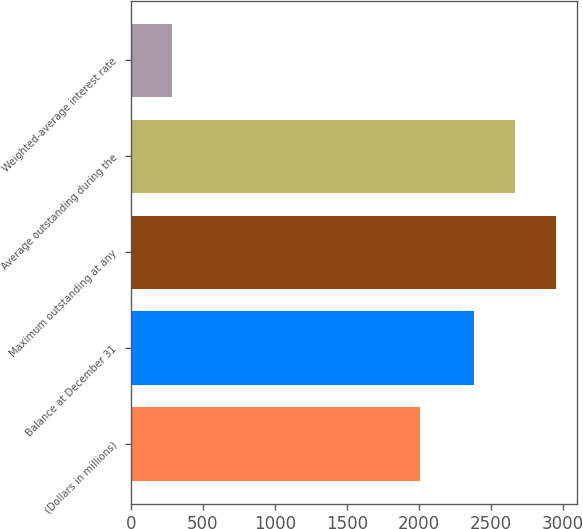Convert chart to OTSL. <chart><loc_0><loc_0><loc_500><loc_500><bar_chart><fcel>(Dollars in millions)<fcel>Balance at December 31<fcel>Maximum outstanding at any<fcel>Average outstanding during the<fcel>Weighted-average interest rate<nl><fcel>2011<fcel>2384<fcel>2948.96<fcel>2666.48<fcel>282.7<nl></chart> 